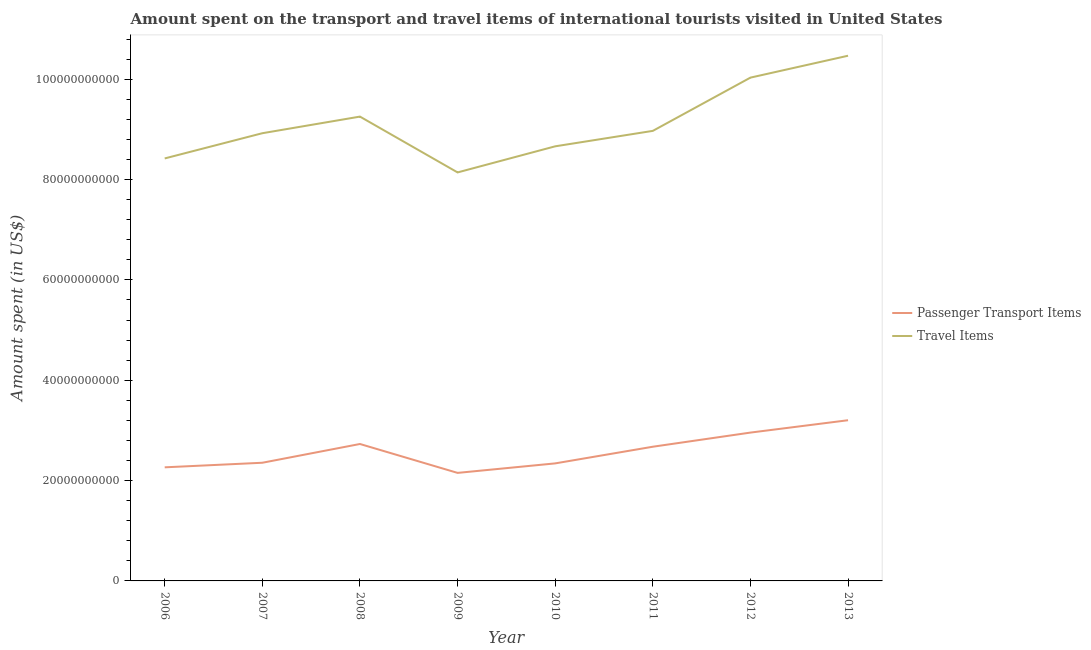How many different coloured lines are there?
Ensure brevity in your answer.  2. Is the number of lines equal to the number of legend labels?
Make the answer very short. Yes. What is the amount spent in travel items in 2009?
Your response must be concise. 8.14e+1. Across all years, what is the maximum amount spent on passenger transport items?
Provide a succinct answer. 3.20e+1. Across all years, what is the minimum amount spent on passenger transport items?
Your response must be concise. 2.15e+1. In which year was the amount spent in travel items maximum?
Provide a succinct answer. 2013. In which year was the amount spent on passenger transport items minimum?
Keep it short and to the point. 2009. What is the total amount spent on passenger transport items in the graph?
Your answer should be compact. 2.07e+11. What is the difference between the amount spent on passenger transport items in 2006 and that in 2013?
Your response must be concise. -9.39e+09. What is the difference between the amount spent in travel items in 2010 and the amount spent on passenger transport items in 2009?
Your answer should be compact. 6.51e+1. What is the average amount spent in travel items per year?
Your answer should be very brief. 9.11e+1. In the year 2009, what is the difference between the amount spent in travel items and amount spent on passenger transport items?
Offer a terse response. 5.99e+1. What is the ratio of the amount spent in travel items in 2007 to that in 2012?
Ensure brevity in your answer.  0.89. What is the difference between the highest and the second highest amount spent on passenger transport items?
Make the answer very short. 2.46e+09. What is the difference between the highest and the lowest amount spent on passenger transport items?
Provide a short and direct response. 1.05e+1. In how many years, is the amount spent on passenger transport items greater than the average amount spent on passenger transport items taken over all years?
Give a very brief answer. 4. Is the sum of the amount spent in travel items in 2007 and 2012 greater than the maximum amount spent on passenger transport items across all years?
Make the answer very short. Yes. Does the amount spent in travel items monotonically increase over the years?
Give a very brief answer. No. Is the amount spent in travel items strictly greater than the amount spent on passenger transport items over the years?
Keep it short and to the point. Yes. How many years are there in the graph?
Your answer should be very brief. 8. Are the values on the major ticks of Y-axis written in scientific E-notation?
Give a very brief answer. No. Does the graph contain any zero values?
Give a very brief answer. No. Does the graph contain grids?
Ensure brevity in your answer.  No. What is the title of the graph?
Offer a terse response. Amount spent on the transport and travel items of international tourists visited in United States. Does "Urban" appear as one of the legend labels in the graph?
Ensure brevity in your answer.  No. What is the label or title of the Y-axis?
Your answer should be very brief. Amount spent (in US$). What is the Amount spent (in US$) in Passenger Transport Items in 2006?
Your answer should be very brief. 2.26e+1. What is the Amount spent (in US$) in Travel Items in 2006?
Make the answer very short. 8.42e+1. What is the Amount spent (in US$) in Passenger Transport Items in 2007?
Your response must be concise. 2.36e+1. What is the Amount spent (in US$) of Travel Items in 2007?
Provide a short and direct response. 8.92e+1. What is the Amount spent (in US$) of Passenger Transport Items in 2008?
Offer a very short reply. 2.73e+1. What is the Amount spent (in US$) of Travel Items in 2008?
Offer a very short reply. 9.25e+1. What is the Amount spent (in US$) in Passenger Transport Items in 2009?
Your answer should be compact. 2.15e+1. What is the Amount spent (in US$) of Travel Items in 2009?
Your answer should be compact. 8.14e+1. What is the Amount spent (in US$) of Passenger Transport Items in 2010?
Offer a very short reply. 2.34e+1. What is the Amount spent (in US$) in Travel Items in 2010?
Offer a very short reply. 8.66e+1. What is the Amount spent (in US$) of Passenger Transport Items in 2011?
Provide a short and direct response. 2.67e+1. What is the Amount spent (in US$) of Travel Items in 2011?
Offer a terse response. 8.97e+1. What is the Amount spent (in US$) of Passenger Transport Items in 2012?
Provide a short and direct response. 2.96e+1. What is the Amount spent (in US$) in Travel Items in 2012?
Give a very brief answer. 1.00e+11. What is the Amount spent (in US$) in Passenger Transport Items in 2013?
Keep it short and to the point. 3.20e+1. What is the Amount spent (in US$) of Travel Items in 2013?
Provide a succinct answer. 1.05e+11. Across all years, what is the maximum Amount spent (in US$) in Passenger Transport Items?
Provide a succinct answer. 3.20e+1. Across all years, what is the maximum Amount spent (in US$) in Travel Items?
Your response must be concise. 1.05e+11. Across all years, what is the minimum Amount spent (in US$) in Passenger Transport Items?
Offer a terse response. 2.15e+1. Across all years, what is the minimum Amount spent (in US$) of Travel Items?
Provide a short and direct response. 8.14e+1. What is the total Amount spent (in US$) in Passenger Transport Items in the graph?
Provide a succinct answer. 2.07e+11. What is the total Amount spent (in US$) in Travel Items in the graph?
Offer a terse response. 7.29e+11. What is the difference between the Amount spent (in US$) in Passenger Transport Items in 2006 and that in 2007?
Provide a short and direct response. -9.11e+08. What is the difference between the Amount spent (in US$) of Travel Items in 2006 and that in 2007?
Offer a very short reply. -5.03e+09. What is the difference between the Amount spent (in US$) of Passenger Transport Items in 2006 and that in 2008?
Offer a very short reply. -4.65e+09. What is the difference between the Amount spent (in US$) in Travel Items in 2006 and that in 2008?
Offer a very short reply. -8.34e+09. What is the difference between the Amount spent (in US$) of Passenger Transport Items in 2006 and that in 2009?
Make the answer very short. 1.11e+09. What is the difference between the Amount spent (in US$) of Travel Items in 2006 and that in 2009?
Offer a terse response. 2.78e+09. What is the difference between the Amount spent (in US$) of Passenger Transport Items in 2006 and that in 2010?
Provide a succinct answer. -7.84e+08. What is the difference between the Amount spent (in US$) in Travel Items in 2006 and that in 2010?
Ensure brevity in your answer.  -2.42e+09. What is the difference between the Amount spent (in US$) of Passenger Transport Items in 2006 and that in 2011?
Your response must be concise. -4.10e+09. What is the difference between the Amount spent (in US$) of Travel Items in 2006 and that in 2011?
Your answer should be very brief. -5.50e+09. What is the difference between the Amount spent (in US$) in Passenger Transport Items in 2006 and that in 2012?
Your answer should be compact. -6.92e+09. What is the difference between the Amount spent (in US$) of Travel Items in 2006 and that in 2012?
Offer a terse response. -1.61e+1. What is the difference between the Amount spent (in US$) of Passenger Transport Items in 2006 and that in 2013?
Provide a short and direct response. -9.39e+09. What is the difference between the Amount spent (in US$) in Travel Items in 2006 and that in 2013?
Give a very brief answer. -2.05e+1. What is the difference between the Amount spent (in US$) in Passenger Transport Items in 2007 and that in 2008?
Provide a short and direct response. -3.74e+09. What is the difference between the Amount spent (in US$) of Travel Items in 2007 and that in 2008?
Ensure brevity in your answer.  -3.31e+09. What is the difference between the Amount spent (in US$) in Passenger Transport Items in 2007 and that in 2009?
Your response must be concise. 2.02e+09. What is the difference between the Amount spent (in US$) in Travel Items in 2007 and that in 2009?
Your answer should be very brief. 7.81e+09. What is the difference between the Amount spent (in US$) in Passenger Transport Items in 2007 and that in 2010?
Your answer should be compact. 1.27e+08. What is the difference between the Amount spent (in US$) of Travel Items in 2007 and that in 2010?
Your response must be concise. 2.61e+09. What is the difference between the Amount spent (in US$) in Passenger Transport Items in 2007 and that in 2011?
Provide a succinct answer. -3.19e+09. What is the difference between the Amount spent (in US$) of Travel Items in 2007 and that in 2011?
Provide a short and direct response. -4.66e+08. What is the difference between the Amount spent (in US$) of Passenger Transport Items in 2007 and that in 2012?
Offer a very short reply. -6.01e+09. What is the difference between the Amount spent (in US$) in Travel Items in 2007 and that in 2012?
Ensure brevity in your answer.  -1.11e+1. What is the difference between the Amount spent (in US$) of Passenger Transport Items in 2007 and that in 2013?
Your response must be concise. -8.48e+09. What is the difference between the Amount spent (in US$) in Travel Items in 2007 and that in 2013?
Your response must be concise. -1.54e+1. What is the difference between the Amount spent (in US$) in Passenger Transport Items in 2008 and that in 2009?
Your response must be concise. 5.76e+09. What is the difference between the Amount spent (in US$) of Travel Items in 2008 and that in 2009?
Keep it short and to the point. 1.11e+1. What is the difference between the Amount spent (in US$) in Passenger Transport Items in 2008 and that in 2010?
Your response must be concise. 3.87e+09. What is the difference between the Amount spent (in US$) in Travel Items in 2008 and that in 2010?
Give a very brief answer. 5.92e+09. What is the difference between the Amount spent (in US$) of Passenger Transport Items in 2008 and that in 2011?
Keep it short and to the point. 5.45e+08. What is the difference between the Amount spent (in US$) of Travel Items in 2008 and that in 2011?
Provide a short and direct response. 2.84e+09. What is the difference between the Amount spent (in US$) in Passenger Transport Items in 2008 and that in 2012?
Offer a terse response. -2.27e+09. What is the difference between the Amount spent (in US$) of Travel Items in 2008 and that in 2012?
Provide a succinct answer. -7.77e+09. What is the difference between the Amount spent (in US$) of Passenger Transport Items in 2008 and that in 2013?
Provide a short and direct response. -4.74e+09. What is the difference between the Amount spent (in US$) of Travel Items in 2008 and that in 2013?
Make the answer very short. -1.21e+1. What is the difference between the Amount spent (in US$) in Passenger Transport Items in 2009 and that in 2010?
Your response must be concise. -1.89e+09. What is the difference between the Amount spent (in US$) in Travel Items in 2009 and that in 2010?
Keep it short and to the point. -5.20e+09. What is the difference between the Amount spent (in US$) of Passenger Transport Items in 2009 and that in 2011?
Keep it short and to the point. -5.22e+09. What is the difference between the Amount spent (in US$) in Travel Items in 2009 and that in 2011?
Provide a succinct answer. -8.28e+09. What is the difference between the Amount spent (in US$) in Passenger Transport Items in 2009 and that in 2012?
Make the answer very short. -8.03e+09. What is the difference between the Amount spent (in US$) of Travel Items in 2009 and that in 2012?
Keep it short and to the point. -1.89e+1. What is the difference between the Amount spent (in US$) of Passenger Transport Items in 2009 and that in 2013?
Keep it short and to the point. -1.05e+1. What is the difference between the Amount spent (in US$) of Travel Items in 2009 and that in 2013?
Your answer should be very brief. -2.33e+1. What is the difference between the Amount spent (in US$) of Passenger Transport Items in 2010 and that in 2011?
Offer a terse response. -3.32e+09. What is the difference between the Amount spent (in US$) of Travel Items in 2010 and that in 2011?
Make the answer very short. -3.08e+09. What is the difference between the Amount spent (in US$) in Passenger Transport Items in 2010 and that in 2012?
Keep it short and to the point. -6.14e+09. What is the difference between the Amount spent (in US$) of Travel Items in 2010 and that in 2012?
Your response must be concise. -1.37e+1. What is the difference between the Amount spent (in US$) of Passenger Transport Items in 2010 and that in 2013?
Provide a succinct answer. -8.60e+09. What is the difference between the Amount spent (in US$) in Travel Items in 2010 and that in 2013?
Your answer should be compact. -1.81e+1. What is the difference between the Amount spent (in US$) of Passenger Transport Items in 2011 and that in 2012?
Offer a very short reply. -2.82e+09. What is the difference between the Amount spent (in US$) of Travel Items in 2011 and that in 2012?
Provide a short and direct response. -1.06e+1. What is the difference between the Amount spent (in US$) in Passenger Transport Items in 2011 and that in 2013?
Make the answer very short. -5.28e+09. What is the difference between the Amount spent (in US$) of Travel Items in 2011 and that in 2013?
Your response must be concise. -1.50e+1. What is the difference between the Amount spent (in US$) of Passenger Transport Items in 2012 and that in 2013?
Your answer should be compact. -2.46e+09. What is the difference between the Amount spent (in US$) of Travel Items in 2012 and that in 2013?
Ensure brevity in your answer.  -4.36e+09. What is the difference between the Amount spent (in US$) of Passenger Transport Items in 2006 and the Amount spent (in US$) of Travel Items in 2007?
Make the answer very short. -6.66e+1. What is the difference between the Amount spent (in US$) in Passenger Transport Items in 2006 and the Amount spent (in US$) in Travel Items in 2008?
Your answer should be compact. -6.99e+1. What is the difference between the Amount spent (in US$) of Passenger Transport Items in 2006 and the Amount spent (in US$) of Travel Items in 2009?
Your answer should be compact. -5.88e+1. What is the difference between the Amount spent (in US$) in Passenger Transport Items in 2006 and the Amount spent (in US$) in Travel Items in 2010?
Offer a very short reply. -6.40e+1. What is the difference between the Amount spent (in US$) in Passenger Transport Items in 2006 and the Amount spent (in US$) in Travel Items in 2011?
Provide a succinct answer. -6.71e+1. What is the difference between the Amount spent (in US$) in Passenger Transport Items in 2006 and the Amount spent (in US$) in Travel Items in 2012?
Offer a terse response. -7.77e+1. What is the difference between the Amount spent (in US$) in Passenger Transport Items in 2006 and the Amount spent (in US$) in Travel Items in 2013?
Provide a succinct answer. -8.20e+1. What is the difference between the Amount spent (in US$) of Passenger Transport Items in 2007 and the Amount spent (in US$) of Travel Items in 2008?
Keep it short and to the point. -6.90e+1. What is the difference between the Amount spent (in US$) in Passenger Transport Items in 2007 and the Amount spent (in US$) in Travel Items in 2009?
Keep it short and to the point. -5.79e+1. What is the difference between the Amount spent (in US$) in Passenger Transport Items in 2007 and the Amount spent (in US$) in Travel Items in 2010?
Offer a terse response. -6.31e+1. What is the difference between the Amount spent (in US$) in Passenger Transport Items in 2007 and the Amount spent (in US$) in Travel Items in 2011?
Offer a very short reply. -6.61e+1. What is the difference between the Amount spent (in US$) in Passenger Transport Items in 2007 and the Amount spent (in US$) in Travel Items in 2012?
Your response must be concise. -7.68e+1. What is the difference between the Amount spent (in US$) of Passenger Transport Items in 2007 and the Amount spent (in US$) of Travel Items in 2013?
Offer a terse response. -8.11e+1. What is the difference between the Amount spent (in US$) in Passenger Transport Items in 2008 and the Amount spent (in US$) in Travel Items in 2009?
Provide a succinct answer. -5.41e+1. What is the difference between the Amount spent (in US$) of Passenger Transport Items in 2008 and the Amount spent (in US$) of Travel Items in 2010?
Offer a terse response. -5.93e+1. What is the difference between the Amount spent (in US$) in Passenger Transport Items in 2008 and the Amount spent (in US$) in Travel Items in 2011?
Give a very brief answer. -6.24e+1. What is the difference between the Amount spent (in US$) in Passenger Transport Items in 2008 and the Amount spent (in US$) in Travel Items in 2012?
Your answer should be very brief. -7.30e+1. What is the difference between the Amount spent (in US$) of Passenger Transport Items in 2008 and the Amount spent (in US$) of Travel Items in 2013?
Give a very brief answer. -7.74e+1. What is the difference between the Amount spent (in US$) of Passenger Transport Items in 2009 and the Amount spent (in US$) of Travel Items in 2010?
Offer a terse response. -6.51e+1. What is the difference between the Amount spent (in US$) in Passenger Transport Items in 2009 and the Amount spent (in US$) in Travel Items in 2011?
Your answer should be very brief. -6.82e+1. What is the difference between the Amount spent (in US$) of Passenger Transport Items in 2009 and the Amount spent (in US$) of Travel Items in 2012?
Give a very brief answer. -7.88e+1. What is the difference between the Amount spent (in US$) of Passenger Transport Items in 2009 and the Amount spent (in US$) of Travel Items in 2013?
Keep it short and to the point. -8.31e+1. What is the difference between the Amount spent (in US$) of Passenger Transport Items in 2010 and the Amount spent (in US$) of Travel Items in 2011?
Your answer should be compact. -6.63e+1. What is the difference between the Amount spent (in US$) in Passenger Transport Items in 2010 and the Amount spent (in US$) in Travel Items in 2012?
Make the answer very short. -7.69e+1. What is the difference between the Amount spent (in US$) of Passenger Transport Items in 2010 and the Amount spent (in US$) of Travel Items in 2013?
Keep it short and to the point. -8.13e+1. What is the difference between the Amount spent (in US$) in Passenger Transport Items in 2011 and the Amount spent (in US$) in Travel Items in 2012?
Keep it short and to the point. -7.36e+1. What is the difference between the Amount spent (in US$) of Passenger Transport Items in 2011 and the Amount spent (in US$) of Travel Items in 2013?
Ensure brevity in your answer.  -7.79e+1. What is the difference between the Amount spent (in US$) of Passenger Transport Items in 2012 and the Amount spent (in US$) of Travel Items in 2013?
Keep it short and to the point. -7.51e+1. What is the average Amount spent (in US$) of Passenger Transport Items per year?
Your answer should be very brief. 2.58e+1. What is the average Amount spent (in US$) of Travel Items per year?
Ensure brevity in your answer.  9.11e+1. In the year 2006, what is the difference between the Amount spent (in US$) of Passenger Transport Items and Amount spent (in US$) of Travel Items?
Offer a terse response. -6.16e+1. In the year 2007, what is the difference between the Amount spent (in US$) of Passenger Transport Items and Amount spent (in US$) of Travel Items?
Ensure brevity in your answer.  -6.57e+1. In the year 2008, what is the difference between the Amount spent (in US$) in Passenger Transport Items and Amount spent (in US$) in Travel Items?
Offer a very short reply. -6.53e+1. In the year 2009, what is the difference between the Amount spent (in US$) in Passenger Transport Items and Amount spent (in US$) in Travel Items?
Keep it short and to the point. -5.99e+1. In the year 2010, what is the difference between the Amount spent (in US$) in Passenger Transport Items and Amount spent (in US$) in Travel Items?
Ensure brevity in your answer.  -6.32e+1. In the year 2011, what is the difference between the Amount spent (in US$) in Passenger Transport Items and Amount spent (in US$) in Travel Items?
Make the answer very short. -6.30e+1. In the year 2012, what is the difference between the Amount spent (in US$) of Passenger Transport Items and Amount spent (in US$) of Travel Items?
Provide a succinct answer. -7.08e+1. In the year 2013, what is the difference between the Amount spent (in US$) in Passenger Transport Items and Amount spent (in US$) in Travel Items?
Make the answer very short. -7.26e+1. What is the ratio of the Amount spent (in US$) of Passenger Transport Items in 2006 to that in 2007?
Give a very brief answer. 0.96. What is the ratio of the Amount spent (in US$) of Travel Items in 2006 to that in 2007?
Offer a terse response. 0.94. What is the ratio of the Amount spent (in US$) in Passenger Transport Items in 2006 to that in 2008?
Offer a terse response. 0.83. What is the ratio of the Amount spent (in US$) of Travel Items in 2006 to that in 2008?
Ensure brevity in your answer.  0.91. What is the ratio of the Amount spent (in US$) in Passenger Transport Items in 2006 to that in 2009?
Provide a short and direct response. 1.05. What is the ratio of the Amount spent (in US$) in Travel Items in 2006 to that in 2009?
Provide a short and direct response. 1.03. What is the ratio of the Amount spent (in US$) in Passenger Transport Items in 2006 to that in 2010?
Ensure brevity in your answer.  0.97. What is the ratio of the Amount spent (in US$) of Travel Items in 2006 to that in 2010?
Ensure brevity in your answer.  0.97. What is the ratio of the Amount spent (in US$) of Passenger Transport Items in 2006 to that in 2011?
Give a very brief answer. 0.85. What is the ratio of the Amount spent (in US$) in Travel Items in 2006 to that in 2011?
Keep it short and to the point. 0.94. What is the ratio of the Amount spent (in US$) in Passenger Transport Items in 2006 to that in 2012?
Make the answer very short. 0.77. What is the ratio of the Amount spent (in US$) in Travel Items in 2006 to that in 2012?
Provide a succinct answer. 0.84. What is the ratio of the Amount spent (in US$) in Passenger Transport Items in 2006 to that in 2013?
Offer a terse response. 0.71. What is the ratio of the Amount spent (in US$) in Travel Items in 2006 to that in 2013?
Make the answer very short. 0.8. What is the ratio of the Amount spent (in US$) in Passenger Transport Items in 2007 to that in 2008?
Give a very brief answer. 0.86. What is the ratio of the Amount spent (in US$) of Travel Items in 2007 to that in 2008?
Your response must be concise. 0.96. What is the ratio of the Amount spent (in US$) of Passenger Transport Items in 2007 to that in 2009?
Your answer should be compact. 1.09. What is the ratio of the Amount spent (in US$) of Travel Items in 2007 to that in 2009?
Ensure brevity in your answer.  1.1. What is the ratio of the Amount spent (in US$) in Passenger Transport Items in 2007 to that in 2010?
Ensure brevity in your answer.  1.01. What is the ratio of the Amount spent (in US$) in Travel Items in 2007 to that in 2010?
Your answer should be compact. 1.03. What is the ratio of the Amount spent (in US$) of Passenger Transport Items in 2007 to that in 2011?
Give a very brief answer. 0.88. What is the ratio of the Amount spent (in US$) in Passenger Transport Items in 2007 to that in 2012?
Offer a very short reply. 0.8. What is the ratio of the Amount spent (in US$) of Travel Items in 2007 to that in 2012?
Ensure brevity in your answer.  0.89. What is the ratio of the Amount spent (in US$) in Passenger Transport Items in 2007 to that in 2013?
Provide a succinct answer. 0.74. What is the ratio of the Amount spent (in US$) of Travel Items in 2007 to that in 2013?
Ensure brevity in your answer.  0.85. What is the ratio of the Amount spent (in US$) in Passenger Transport Items in 2008 to that in 2009?
Provide a succinct answer. 1.27. What is the ratio of the Amount spent (in US$) of Travel Items in 2008 to that in 2009?
Offer a terse response. 1.14. What is the ratio of the Amount spent (in US$) of Passenger Transport Items in 2008 to that in 2010?
Provide a short and direct response. 1.17. What is the ratio of the Amount spent (in US$) of Travel Items in 2008 to that in 2010?
Ensure brevity in your answer.  1.07. What is the ratio of the Amount spent (in US$) of Passenger Transport Items in 2008 to that in 2011?
Make the answer very short. 1.02. What is the ratio of the Amount spent (in US$) of Travel Items in 2008 to that in 2011?
Keep it short and to the point. 1.03. What is the ratio of the Amount spent (in US$) of Passenger Transport Items in 2008 to that in 2012?
Offer a very short reply. 0.92. What is the ratio of the Amount spent (in US$) in Travel Items in 2008 to that in 2012?
Your answer should be compact. 0.92. What is the ratio of the Amount spent (in US$) in Passenger Transport Items in 2008 to that in 2013?
Keep it short and to the point. 0.85. What is the ratio of the Amount spent (in US$) in Travel Items in 2008 to that in 2013?
Give a very brief answer. 0.88. What is the ratio of the Amount spent (in US$) in Passenger Transport Items in 2009 to that in 2010?
Make the answer very short. 0.92. What is the ratio of the Amount spent (in US$) of Travel Items in 2009 to that in 2010?
Give a very brief answer. 0.94. What is the ratio of the Amount spent (in US$) in Passenger Transport Items in 2009 to that in 2011?
Ensure brevity in your answer.  0.81. What is the ratio of the Amount spent (in US$) of Travel Items in 2009 to that in 2011?
Give a very brief answer. 0.91. What is the ratio of the Amount spent (in US$) in Passenger Transport Items in 2009 to that in 2012?
Your response must be concise. 0.73. What is the ratio of the Amount spent (in US$) of Travel Items in 2009 to that in 2012?
Your answer should be very brief. 0.81. What is the ratio of the Amount spent (in US$) in Passenger Transport Items in 2009 to that in 2013?
Your answer should be compact. 0.67. What is the ratio of the Amount spent (in US$) of Travel Items in 2009 to that in 2013?
Your answer should be very brief. 0.78. What is the ratio of the Amount spent (in US$) in Passenger Transport Items in 2010 to that in 2011?
Offer a very short reply. 0.88. What is the ratio of the Amount spent (in US$) of Travel Items in 2010 to that in 2011?
Your answer should be very brief. 0.97. What is the ratio of the Amount spent (in US$) in Passenger Transport Items in 2010 to that in 2012?
Make the answer very short. 0.79. What is the ratio of the Amount spent (in US$) of Travel Items in 2010 to that in 2012?
Offer a very short reply. 0.86. What is the ratio of the Amount spent (in US$) in Passenger Transport Items in 2010 to that in 2013?
Give a very brief answer. 0.73. What is the ratio of the Amount spent (in US$) of Travel Items in 2010 to that in 2013?
Offer a terse response. 0.83. What is the ratio of the Amount spent (in US$) of Passenger Transport Items in 2011 to that in 2012?
Offer a terse response. 0.9. What is the ratio of the Amount spent (in US$) of Travel Items in 2011 to that in 2012?
Provide a short and direct response. 0.89. What is the ratio of the Amount spent (in US$) in Passenger Transport Items in 2011 to that in 2013?
Make the answer very short. 0.84. What is the ratio of the Amount spent (in US$) in Travel Items in 2011 to that in 2013?
Give a very brief answer. 0.86. What is the ratio of the Amount spent (in US$) in Passenger Transport Items in 2012 to that in 2013?
Your answer should be compact. 0.92. What is the difference between the highest and the second highest Amount spent (in US$) in Passenger Transport Items?
Give a very brief answer. 2.46e+09. What is the difference between the highest and the second highest Amount spent (in US$) of Travel Items?
Provide a succinct answer. 4.36e+09. What is the difference between the highest and the lowest Amount spent (in US$) of Passenger Transport Items?
Offer a very short reply. 1.05e+1. What is the difference between the highest and the lowest Amount spent (in US$) in Travel Items?
Ensure brevity in your answer.  2.33e+1. 